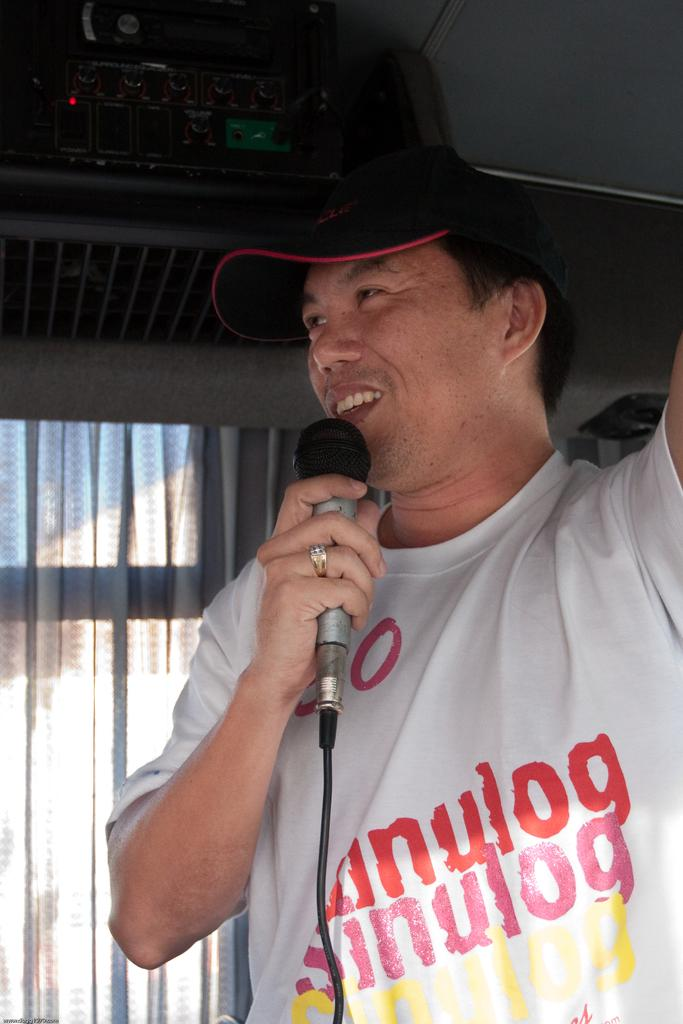What is the man in the image doing? The man is holding a microphone in his hand and speaking. What object is the man holding in the image? The man is holding a microphone in his hand. What can be seen in the background of the image? There is a window and a curtain associated with the window in the image. How many tickets does the man have in his hand in the image? There are no tickets visible in the image; the man is holding a microphone. What type of bottle is the man holding in the image? The man is not holding a bottle in the image; he is holding a microphone. 